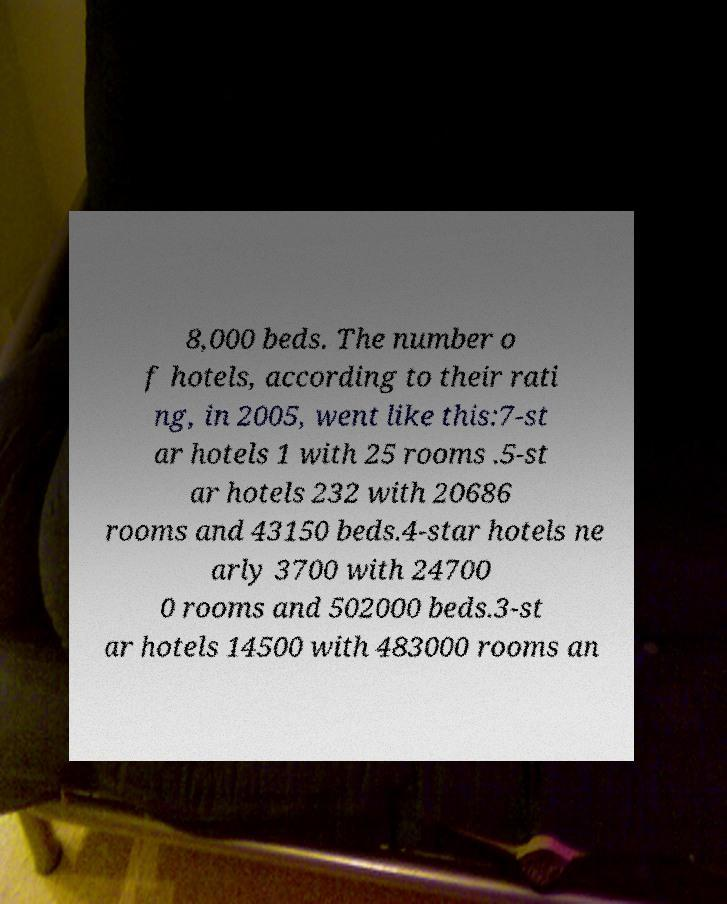What messages or text are displayed in this image? I need them in a readable, typed format. 8,000 beds. The number o f hotels, according to their rati ng, in 2005, went like this:7-st ar hotels 1 with 25 rooms .5-st ar hotels 232 with 20686 rooms and 43150 beds.4-star hotels ne arly 3700 with 24700 0 rooms and 502000 beds.3-st ar hotels 14500 with 483000 rooms an 